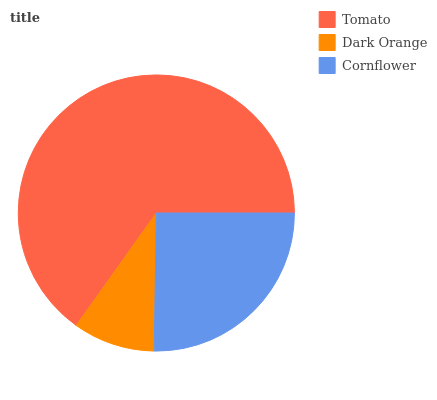Is Dark Orange the minimum?
Answer yes or no. Yes. Is Tomato the maximum?
Answer yes or no. Yes. Is Cornflower the minimum?
Answer yes or no. No. Is Cornflower the maximum?
Answer yes or no. No. Is Cornflower greater than Dark Orange?
Answer yes or no. Yes. Is Dark Orange less than Cornflower?
Answer yes or no. Yes. Is Dark Orange greater than Cornflower?
Answer yes or no. No. Is Cornflower less than Dark Orange?
Answer yes or no. No. Is Cornflower the high median?
Answer yes or no. Yes. Is Cornflower the low median?
Answer yes or no. Yes. Is Tomato the high median?
Answer yes or no. No. Is Dark Orange the low median?
Answer yes or no. No. 